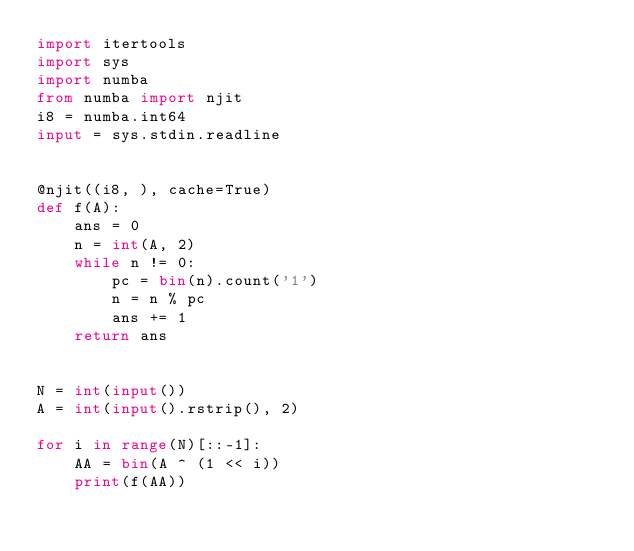Convert code to text. <code><loc_0><loc_0><loc_500><loc_500><_Python_>import itertools
import sys
import numba
from numba import njit
i8 = numba.int64
input = sys.stdin.readline


@njit((i8, ), cache=True)
def f(A):
    ans = 0
    n = int(A, 2)
    while n != 0:
        pc = bin(n).count('1')
        n = n % pc
        ans += 1
    return ans


N = int(input())
A = int(input().rstrip(), 2)

for i in range(N)[::-1]:
    AA = bin(A ^ (1 << i))
    print(f(AA))
</code> 